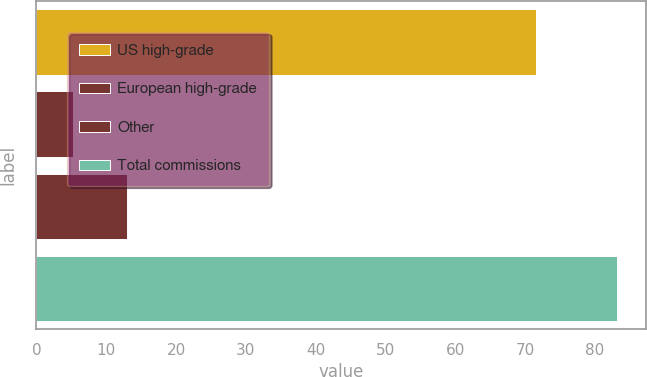<chart> <loc_0><loc_0><loc_500><loc_500><bar_chart><fcel>US high-grade<fcel>European high-grade<fcel>Other<fcel>Total commissions<nl><fcel>71.6<fcel>5.2<fcel>13<fcel>83.2<nl></chart> 